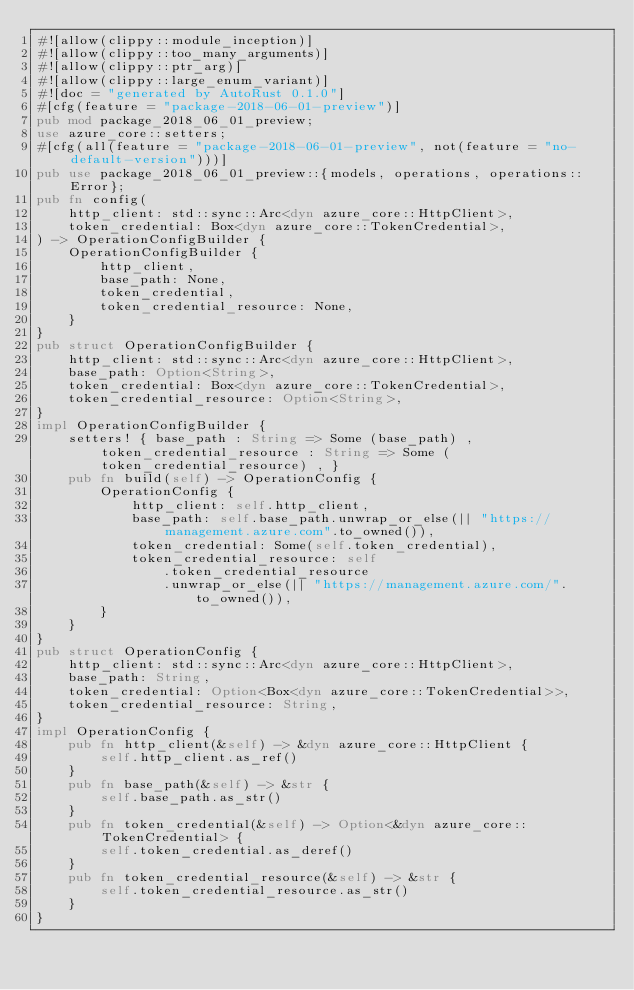Convert code to text. <code><loc_0><loc_0><loc_500><loc_500><_Rust_>#![allow(clippy::module_inception)]
#![allow(clippy::too_many_arguments)]
#![allow(clippy::ptr_arg)]
#![allow(clippy::large_enum_variant)]
#![doc = "generated by AutoRust 0.1.0"]
#[cfg(feature = "package-2018-06-01-preview")]
pub mod package_2018_06_01_preview;
use azure_core::setters;
#[cfg(all(feature = "package-2018-06-01-preview", not(feature = "no-default-version")))]
pub use package_2018_06_01_preview::{models, operations, operations::Error};
pub fn config(
    http_client: std::sync::Arc<dyn azure_core::HttpClient>,
    token_credential: Box<dyn azure_core::TokenCredential>,
) -> OperationConfigBuilder {
    OperationConfigBuilder {
        http_client,
        base_path: None,
        token_credential,
        token_credential_resource: None,
    }
}
pub struct OperationConfigBuilder {
    http_client: std::sync::Arc<dyn azure_core::HttpClient>,
    base_path: Option<String>,
    token_credential: Box<dyn azure_core::TokenCredential>,
    token_credential_resource: Option<String>,
}
impl OperationConfigBuilder {
    setters! { base_path : String => Some (base_path) , token_credential_resource : String => Some (token_credential_resource) , }
    pub fn build(self) -> OperationConfig {
        OperationConfig {
            http_client: self.http_client,
            base_path: self.base_path.unwrap_or_else(|| "https://management.azure.com".to_owned()),
            token_credential: Some(self.token_credential),
            token_credential_resource: self
                .token_credential_resource
                .unwrap_or_else(|| "https://management.azure.com/".to_owned()),
        }
    }
}
pub struct OperationConfig {
    http_client: std::sync::Arc<dyn azure_core::HttpClient>,
    base_path: String,
    token_credential: Option<Box<dyn azure_core::TokenCredential>>,
    token_credential_resource: String,
}
impl OperationConfig {
    pub fn http_client(&self) -> &dyn azure_core::HttpClient {
        self.http_client.as_ref()
    }
    pub fn base_path(&self) -> &str {
        self.base_path.as_str()
    }
    pub fn token_credential(&self) -> Option<&dyn azure_core::TokenCredential> {
        self.token_credential.as_deref()
    }
    pub fn token_credential_resource(&self) -> &str {
        self.token_credential_resource.as_str()
    }
}
</code> 